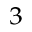Convert formula to latex. <formula><loc_0><loc_0><loc_500><loc_500>^ { 3 }</formula> 